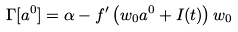<formula> <loc_0><loc_0><loc_500><loc_500>\Gamma [ a ^ { 0 } ] = \alpha - f ^ { \prime } \left ( w _ { 0 } a ^ { 0 } + I ( t ) \right ) w _ { 0 }</formula> 